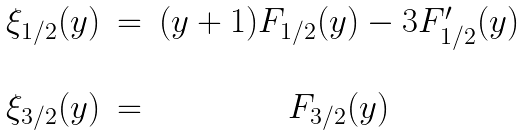<formula> <loc_0><loc_0><loc_500><loc_500>\begin{array} { c c c } \xi _ { 1 / 2 } ( y ) & = & ( y + 1 ) F _ { 1 / 2 } ( y ) - 3 F ^ { \prime } _ { 1 / 2 } ( y ) \\ \\ \xi _ { 3 / 2 } ( y ) & = & F _ { 3 / 2 } ( y ) \\ \end{array}</formula> 